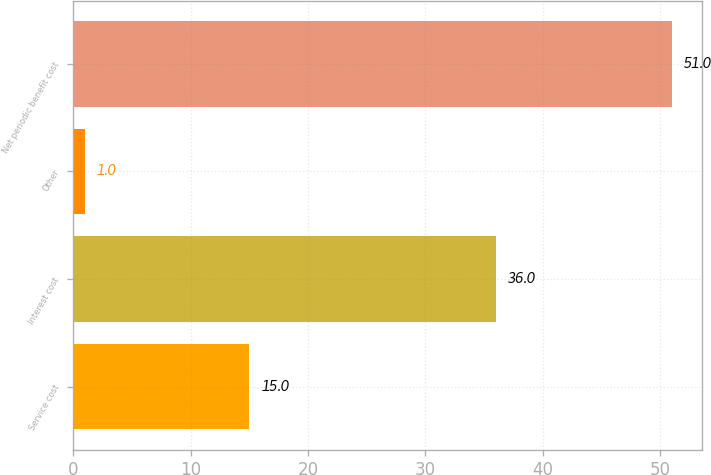Convert chart to OTSL. <chart><loc_0><loc_0><loc_500><loc_500><bar_chart><fcel>Service cost<fcel>Interest cost<fcel>Other<fcel>Net periodic benefit cost<nl><fcel>15<fcel>36<fcel>1<fcel>51<nl></chart> 